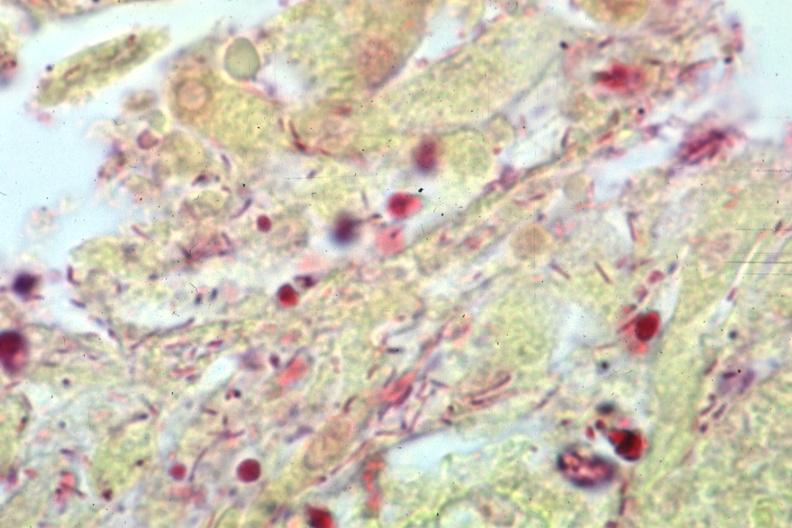s brain present?
Answer the question using a single word or phrase. Yes 